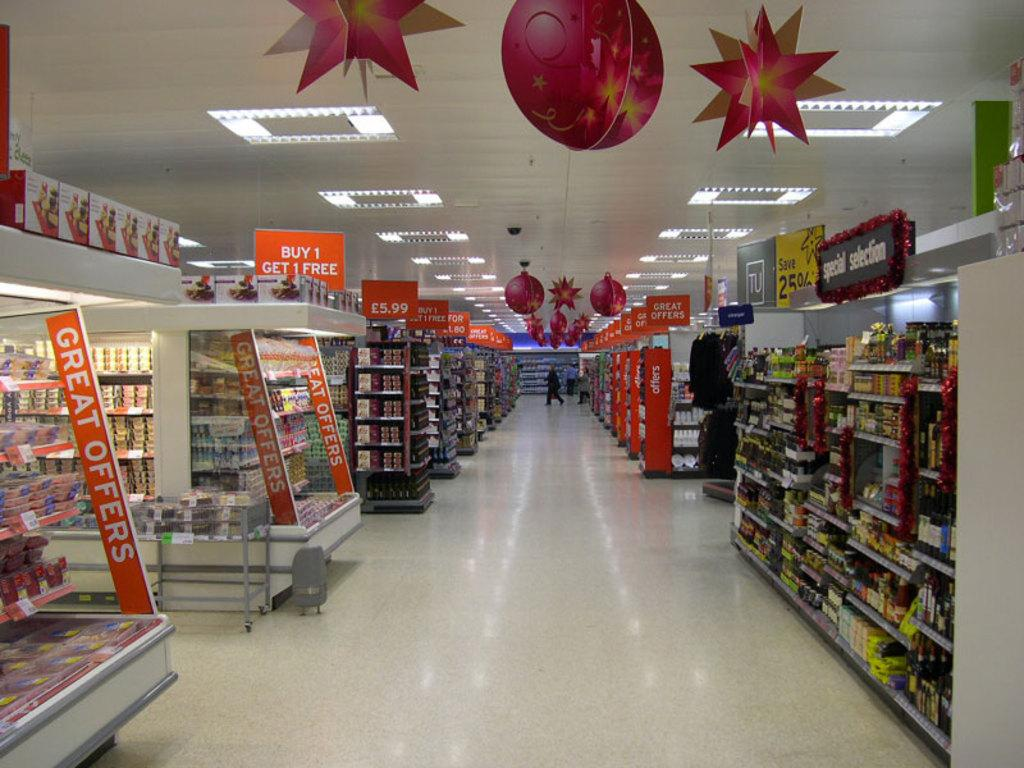<image>
Give a short and clear explanation of the subsequent image. The supermarket shown has alot of great offers for it's customers. 